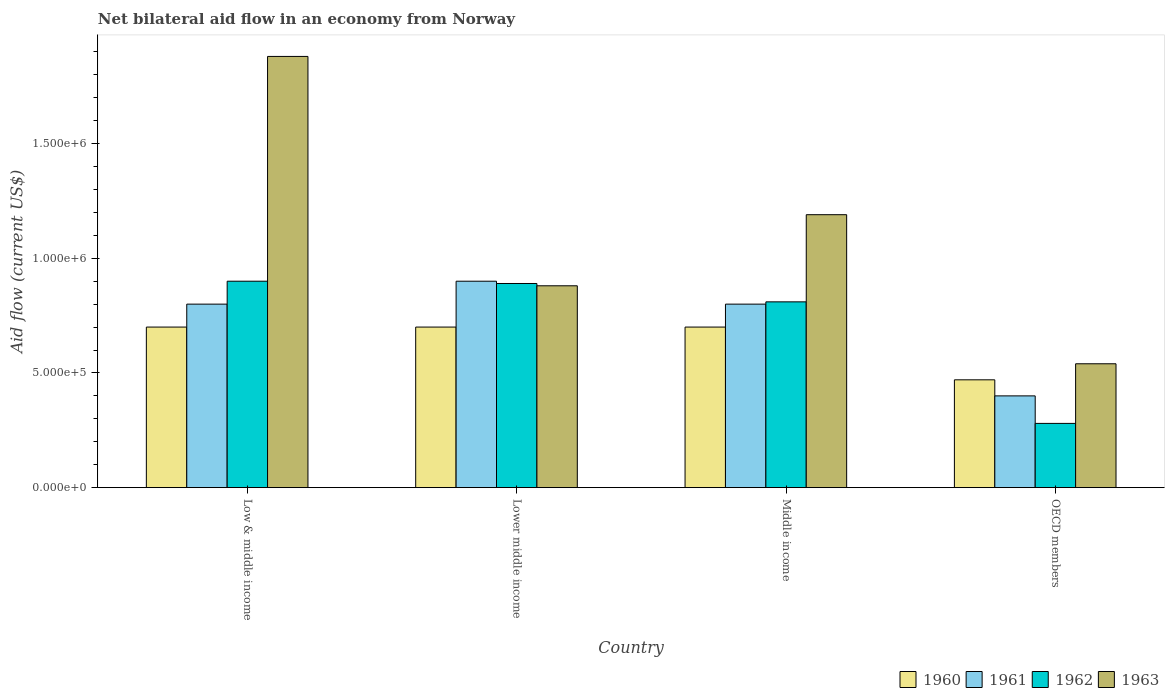How many different coloured bars are there?
Give a very brief answer. 4. Are the number of bars per tick equal to the number of legend labels?
Ensure brevity in your answer.  Yes. Are the number of bars on each tick of the X-axis equal?
Your answer should be very brief. Yes. How many bars are there on the 1st tick from the right?
Offer a terse response. 4. What is the label of the 4th group of bars from the left?
Provide a succinct answer. OECD members. In how many cases, is the number of bars for a given country not equal to the number of legend labels?
Your answer should be very brief. 0. What is the net bilateral aid flow in 1962 in Lower middle income?
Give a very brief answer. 8.90e+05. Across all countries, what is the maximum net bilateral aid flow in 1961?
Provide a succinct answer. 9.00e+05. In which country was the net bilateral aid flow in 1960 maximum?
Offer a terse response. Low & middle income. In which country was the net bilateral aid flow in 1961 minimum?
Make the answer very short. OECD members. What is the total net bilateral aid flow in 1962 in the graph?
Your answer should be very brief. 2.88e+06. What is the difference between the net bilateral aid flow in 1960 in OECD members and the net bilateral aid flow in 1963 in Low & middle income?
Provide a short and direct response. -1.41e+06. What is the average net bilateral aid flow in 1960 per country?
Give a very brief answer. 6.42e+05. What is the ratio of the net bilateral aid flow in 1962 in Low & middle income to that in Lower middle income?
Ensure brevity in your answer.  1.01. Is the net bilateral aid flow in 1963 in Lower middle income less than that in OECD members?
Ensure brevity in your answer.  No. Is the difference between the net bilateral aid flow in 1960 in Low & middle income and OECD members greater than the difference between the net bilateral aid flow in 1961 in Low & middle income and OECD members?
Ensure brevity in your answer.  No. What is the difference between the highest and the second highest net bilateral aid flow in 1962?
Ensure brevity in your answer.  9.00e+04. In how many countries, is the net bilateral aid flow in 1962 greater than the average net bilateral aid flow in 1962 taken over all countries?
Offer a terse response. 3. Is it the case that in every country, the sum of the net bilateral aid flow in 1963 and net bilateral aid flow in 1960 is greater than the sum of net bilateral aid flow in 1961 and net bilateral aid flow in 1962?
Offer a very short reply. No. What does the 3rd bar from the right in Low & middle income represents?
Offer a terse response. 1961. Is it the case that in every country, the sum of the net bilateral aid flow in 1962 and net bilateral aid flow in 1961 is greater than the net bilateral aid flow in 1960?
Offer a very short reply. Yes. How many bars are there?
Give a very brief answer. 16. Are all the bars in the graph horizontal?
Offer a terse response. No. Are the values on the major ticks of Y-axis written in scientific E-notation?
Provide a short and direct response. Yes. Does the graph contain grids?
Your answer should be very brief. No. What is the title of the graph?
Provide a short and direct response. Net bilateral aid flow in an economy from Norway. Does "1961" appear as one of the legend labels in the graph?
Give a very brief answer. Yes. What is the label or title of the X-axis?
Make the answer very short. Country. What is the label or title of the Y-axis?
Offer a very short reply. Aid flow (current US$). What is the Aid flow (current US$) of 1962 in Low & middle income?
Offer a terse response. 9.00e+05. What is the Aid flow (current US$) in 1963 in Low & middle income?
Keep it short and to the point. 1.88e+06. What is the Aid flow (current US$) in 1961 in Lower middle income?
Give a very brief answer. 9.00e+05. What is the Aid flow (current US$) in 1962 in Lower middle income?
Your answer should be compact. 8.90e+05. What is the Aid flow (current US$) in 1963 in Lower middle income?
Your response must be concise. 8.80e+05. What is the Aid flow (current US$) in 1960 in Middle income?
Your response must be concise. 7.00e+05. What is the Aid flow (current US$) in 1961 in Middle income?
Your answer should be compact. 8.00e+05. What is the Aid flow (current US$) in 1962 in Middle income?
Offer a terse response. 8.10e+05. What is the Aid flow (current US$) of 1963 in Middle income?
Your answer should be very brief. 1.19e+06. What is the Aid flow (current US$) in 1961 in OECD members?
Offer a very short reply. 4.00e+05. What is the Aid flow (current US$) in 1963 in OECD members?
Provide a short and direct response. 5.40e+05. Across all countries, what is the maximum Aid flow (current US$) of 1961?
Your response must be concise. 9.00e+05. Across all countries, what is the maximum Aid flow (current US$) of 1962?
Keep it short and to the point. 9.00e+05. Across all countries, what is the maximum Aid flow (current US$) in 1963?
Make the answer very short. 1.88e+06. Across all countries, what is the minimum Aid flow (current US$) of 1960?
Make the answer very short. 4.70e+05. Across all countries, what is the minimum Aid flow (current US$) of 1961?
Keep it short and to the point. 4.00e+05. Across all countries, what is the minimum Aid flow (current US$) in 1963?
Your response must be concise. 5.40e+05. What is the total Aid flow (current US$) of 1960 in the graph?
Offer a terse response. 2.57e+06. What is the total Aid flow (current US$) of 1961 in the graph?
Offer a terse response. 2.90e+06. What is the total Aid flow (current US$) in 1962 in the graph?
Give a very brief answer. 2.88e+06. What is the total Aid flow (current US$) of 1963 in the graph?
Make the answer very short. 4.49e+06. What is the difference between the Aid flow (current US$) of 1961 in Low & middle income and that in Lower middle income?
Offer a terse response. -1.00e+05. What is the difference between the Aid flow (current US$) of 1963 in Low & middle income and that in Lower middle income?
Your answer should be very brief. 1.00e+06. What is the difference between the Aid flow (current US$) of 1961 in Low & middle income and that in Middle income?
Provide a short and direct response. 0. What is the difference between the Aid flow (current US$) in 1962 in Low & middle income and that in Middle income?
Provide a short and direct response. 9.00e+04. What is the difference between the Aid flow (current US$) in 1963 in Low & middle income and that in Middle income?
Ensure brevity in your answer.  6.90e+05. What is the difference between the Aid flow (current US$) in 1960 in Low & middle income and that in OECD members?
Make the answer very short. 2.30e+05. What is the difference between the Aid flow (current US$) of 1962 in Low & middle income and that in OECD members?
Offer a terse response. 6.20e+05. What is the difference between the Aid flow (current US$) of 1963 in Low & middle income and that in OECD members?
Ensure brevity in your answer.  1.34e+06. What is the difference between the Aid flow (current US$) of 1961 in Lower middle income and that in Middle income?
Your answer should be compact. 1.00e+05. What is the difference between the Aid flow (current US$) in 1963 in Lower middle income and that in Middle income?
Make the answer very short. -3.10e+05. What is the difference between the Aid flow (current US$) in 1961 in Lower middle income and that in OECD members?
Provide a short and direct response. 5.00e+05. What is the difference between the Aid flow (current US$) in 1962 in Lower middle income and that in OECD members?
Your answer should be very brief. 6.10e+05. What is the difference between the Aid flow (current US$) of 1962 in Middle income and that in OECD members?
Provide a short and direct response. 5.30e+05. What is the difference between the Aid flow (current US$) in 1963 in Middle income and that in OECD members?
Provide a succinct answer. 6.50e+05. What is the difference between the Aid flow (current US$) in 1960 in Low & middle income and the Aid flow (current US$) in 1961 in Lower middle income?
Keep it short and to the point. -2.00e+05. What is the difference between the Aid flow (current US$) of 1960 in Low & middle income and the Aid flow (current US$) of 1962 in Lower middle income?
Offer a terse response. -1.90e+05. What is the difference between the Aid flow (current US$) of 1960 in Low & middle income and the Aid flow (current US$) of 1961 in Middle income?
Make the answer very short. -1.00e+05. What is the difference between the Aid flow (current US$) in 1960 in Low & middle income and the Aid flow (current US$) in 1963 in Middle income?
Make the answer very short. -4.90e+05. What is the difference between the Aid flow (current US$) of 1961 in Low & middle income and the Aid flow (current US$) of 1962 in Middle income?
Provide a short and direct response. -10000. What is the difference between the Aid flow (current US$) in 1961 in Low & middle income and the Aid flow (current US$) in 1963 in Middle income?
Your answer should be compact. -3.90e+05. What is the difference between the Aid flow (current US$) in 1960 in Low & middle income and the Aid flow (current US$) in 1961 in OECD members?
Your answer should be very brief. 3.00e+05. What is the difference between the Aid flow (current US$) in 1960 in Low & middle income and the Aid flow (current US$) in 1963 in OECD members?
Provide a succinct answer. 1.60e+05. What is the difference between the Aid flow (current US$) in 1961 in Low & middle income and the Aid flow (current US$) in 1962 in OECD members?
Your response must be concise. 5.20e+05. What is the difference between the Aid flow (current US$) in 1961 in Low & middle income and the Aid flow (current US$) in 1963 in OECD members?
Offer a terse response. 2.60e+05. What is the difference between the Aid flow (current US$) of 1960 in Lower middle income and the Aid flow (current US$) of 1962 in Middle income?
Make the answer very short. -1.10e+05. What is the difference between the Aid flow (current US$) in 1960 in Lower middle income and the Aid flow (current US$) in 1963 in Middle income?
Make the answer very short. -4.90e+05. What is the difference between the Aid flow (current US$) of 1960 in Lower middle income and the Aid flow (current US$) of 1962 in OECD members?
Your response must be concise. 4.20e+05. What is the difference between the Aid flow (current US$) in 1961 in Lower middle income and the Aid flow (current US$) in 1962 in OECD members?
Provide a short and direct response. 6.20e+05. What is the difference between the Aid flow (current US$) of 1961 in Lower middle income and the Aid flow (current US$) of 1963 in OECD members?
Offer a very short reply. 3.60e+05. What is the difference between the Aid flow (current US$) of 1962 in Lower middle income and the Aid flow (current US$) of 1963 in OECD members?
Provide a short and direct response. 3.50e+05. What is the difference between the Aid flow (current US$) of 1960 in Middle income and the Aid flow (current US$) of 1961 in OECD members?
Make the answer very short. 3.00e+05. What is the difference between the Aid flow (current US$) in 1960 in Middle income and the Aid flow (current US$) in 1962 in OECD members?
Give a very brief answer. 4.20e+05. What is the difference between the Aid flow (current US$) in 1960 in Middle income and the Aid flow (current US$) in 1963 in OECD members?
Make the answer very short. 1.60e+05. What is the difference between the Aid flow (current US$) in 1961 in Middle income and the Aid flow (current US$) in 1962 in OECD members?
Provide a short and direct response. 5.20e+05. What is the difference between the Aid flow (current US$) in 1961 in Middle income and the Aid flow (current US$) in 1963 in OECD members?
Provide a short and direct response. 2.60e+05. What is the average Aid flow (current US$) of 1960 per country?
Make the answer very short. 6.42e+05. What is the average Aid flow (current US$) in 1961 per country?
Provide a succinct answer. 7.25e+05. What is the average Aid flow (current US$) in 1962 per country?
Make the answer very short. 7.20e+05. What is the average Aid flow (current US$) of 1963 per country?
Your answer should be very brief. 1.12e+06. What is the difference between the Aid flow (current US$) of 1960 and Aid flow (current US$) of 1961 in Low & middle income?
Make the answer very short. -1.00e+05. What is the difference between the Aid flow (current US$) in 1960 and Aid flow (current US$) in 1962 in Low & middle income?
Your answer should be compact. -2.00e+05. What is the difference between the Aid flow (current US$) of 1960 and Aid flow (current US$) of 1963 in Low & middle income?
Provide a succinct answer. -1.18e+06. What is the difference between the Aid flow (current US$) in 1961 and Aid flow (current US$) in 1962 in Low & middle income?
Your answer should be compact. -1.00e+05. What is the difference between the Aid flow (current US$) in 1961 and Aid flow (current US$) in 1963 in Low & middle income?
Your response must be concise. -1.08e+06. What is the difference between the Aid flow (current US$) in 1962 and Aid flow (current US$) in 1963 in Low & middle income?
Your answer should be compact. -9.80e+05. What is the difference between the Aid flow (current US$) of 1960 and Aid flow (current US$) of 1962 in Lower middle income?
Offer a terse response. -1.90e+05. What is the difference between the Aid flow (current US$) in 1961 and Aid flow (current US$) in 1963 in Lower middle income?
Give a very brief answer. 2.00e+04. What is the difference between the Aid flow (current US$) of 1960 and Aid flow (current US$) of 1963 in Middle income?
Provide a short and direct response. -4.90e+05. What is the difference between the Aid flow (current US$) of 1961 and Aid flow (current US$) of 1962 in Middle income?
Keep it short and to the point. -10000. What is the difference between the Aid flow (current US$) of 1961 and Aid flow (current US$) of 1963 in Middle income?
Your response must be concise. -3.90e+05. What is the difference between the Aid flow (current US$) of 1962 and Aid flow (current US$) of 1963 in Middle income?
Ensure brevity in your answer.  -3.80e+05. What is the difference between the Aid flow (current US$) in 1960 and Aid flow (current US$) in 1962 in OECD members?
Provide a short and direct response. 1.90e+05. What is the difference between the Aid flow (current US$) in 1961 and Aid flow (current US$) in 1962 in OECD members?
Give a very brief answer. 1.20e+05. What is the difference between the Aid flow (current US$) of 1961 and Aid flow (current US$) of 1963 in OECD members?
Keep it short and to the point. -1.40e+05. What is the difference between the Aid flow (current US$) of 1962 and Aid flow (current US$) of 1963 in OECD members?
Ensure brevity in your answer.  -2.60e+05. What is the ratio of the Aid flow (current US$) of 1961 in Low & middle income to that in Lower middle income?
Your response must be concise. 0.89. What is the ratio of the Aid flow (current US$) in 1962 in Low & middle income to that in Lower middle income?
Your response must be concise. 1.01. What is the ratio of the Aid flow (current US$) of 1963 in Low & middle income to that in Lower middle income?
Offer a terse response. 2.14. What is the ratio of the Aid flow (current US$) in 1960 in Low & middle income to that in Middle income?
Offer a very short reply. 1. What is the ratio of the Aid flow (current US$) in 1961 in Low & middle income to that in Middle income?
Your response must be concise. 1. What is the ratio of the Aid flow (current US$) in 1962 in Low & middle income to that in Middle income?
Your response must be concise. 1.11. What is the ratio of the Aid flow (current US$) in 1963 in Low & middle income to that in Middle income?
Provide a short and direct response. 1.58. What is the ratio of the Aid flow (current US$) in 1960 in Low & middle income to that in OECD members?
Make the answer very short. 1.49. What is the ratio of the Aid flow (current US$) of 1961 in Low & middle income to that in OECD members?
Make the answer very short. 2. What is the ratio of the Aid flow (current US$) in 1962 in Low & middle income to that in OECD members?
Keep it short and to the point. 3.21. What is the ratio of the Aid flow (current US$) in 1963 in Low & middle income to that in OECD members?
Your answer should be compact. 3.48. What is the ratio of the Aid flow (current US$) of 1962 in Lower middle income to that in Middle income?
Provide a succinct answer. 1.1. What is the ratio of the Aid flow (current US$) in 1963 in Lower middle income to that in Middle income?
Give a very brief answer. 0.74. What is the ratio of the Aid flow (current US$) of 1960 in Lower middle income to that in OECD members?
Your response must be concise. 1.49. What is the ratio of the Aid flow (current US$) in 1961 in Lower middle income to that in OECD members?
Provide a short and direct response. 2.25. What is the ratio of the Aid flow (current US$) of 1962 in Lower middle income to that in OECD members?
Your answer should be compact. 3.18. What is the ratio of the Aid flow (current US$) of 1963 in Lower middle income to that in OECD members?
Your answer should be very brief. 1.63. What is the ratio of the Aid flow (current US$) in 1960 in Middle income to that in OECD members?
Offer a terse response. 1.49. What is the ratio of the Aid flow (current US$) in 1961 in Middle income to that in OECD members?
Offer a very short reply. 2. What is the ratio of the Aid flow (current US$) of 1962 in Middle income to that in OECD members?
Provide a succinct answer. 2.89. What is the ratio of the Aid flow (current US$) in 1963 in Middle income to that in OECD members?
Make the answer very short. 2.2. What is the difference between the highest and the second highest Aid flow (current US$) of 1961?
Provide a succinct answer. 1.00e+05. What is the difference between the highest and the second highest Aid flow (current US$) in 1962?
Keep it short and to the point. 10000. What is the difference between the highest and the second highest Aid flow (current US$) of 1963?
Offer a very short reply. 6.90e+05. What is the difference between the highest and the lowest Aid flow (current US$) of 1962?
Your answer should be very brief. 6.20e+05. What is the difference between the highest and the lowest Aid flow (current US$) of 1963?
Ensure brevity in your answer.  1.34e+06. 